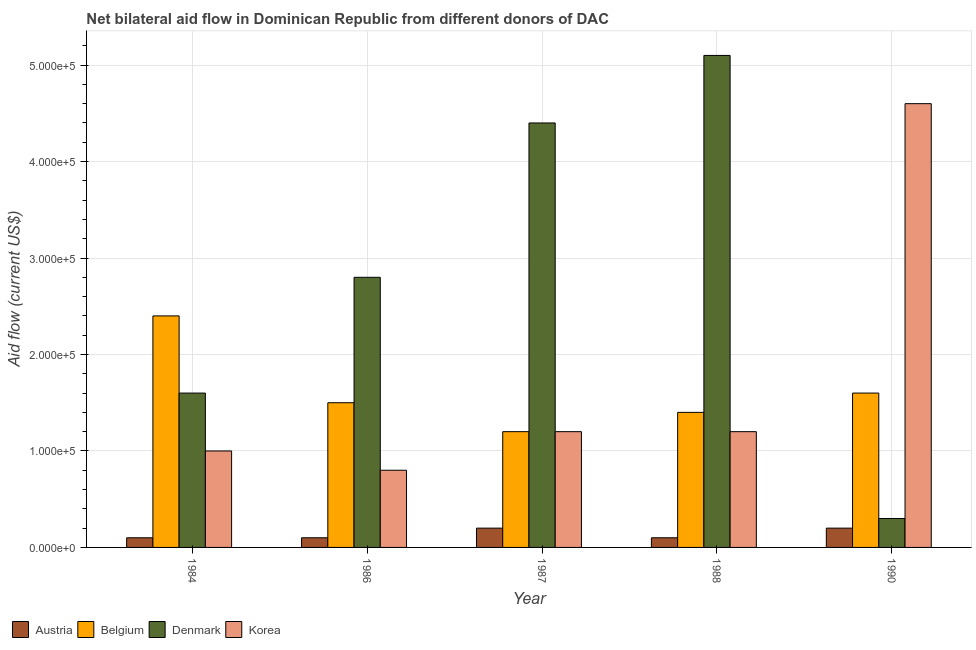How many different coloured bars are there?
Offer a terse response. 4. How many bars are there on the 5th tick from the right?
Ensure brevity in your answer.  4. In how many cases, is the number of bars for a given year not equal to the number of legend labels?
Provide a succinct answer. 0. What is the amount of aid given by austria in 1990?
Your response must be concise. 2.00e+04. Across all years, what is the maximum amount of aid given by belgium?
Offer a terse response. 2.40e+05. Across all years, what is the minimum amount of aid given by belgium?
Give a very brief answer. 1.20e+05. What is the total amount of aid given by korea in the graph?
Ensure brevity in your answer.  8.80e+05. What is the difference between the amount of aid given by austria in 1987 and that in 1988?
Make the answer very short. 10000. What is the difference between the amount of aid given by korea in 1988 and the amount of aid given by belgium in 1986?
Provide a short and direct response. 4.00e+04. What is the average amount of aid given by belgium per year?
Make the answer very short. 1.62e+05. In the year 1987, what is the difference between the amount of aid given by austria and amount of aid given by belgium?
Give a very brief answer. 0. In how many years, is the amount of aid given by belgium greater than 60000 US$?
Make the answer very short. 5. What is the ratio of the amount of aid given by korea in 1988 to that in 1990?
Your answer should be compact. 0.26. What is the difference between the highest and the lowest amount of aid given by denmark?
Give a very brief answer. 4.80e+05. Is it the case that in every year, the sum of the amount of aid given by denmark and amount of aid given by korea is greater than the sum of amount of aid given by austria and amount of aid given by belgium?
Keep it short and to the point. No. What does the 4th bar from the left in 1984 represents?
Your answer should be very brief. Korea. What does the 1st bar from the right in 1986 represents?
Your answer should be compact. Korea. Is it the case that in every year, the sum of the amount of aid given by austria and amount of aid given by belgium is greater than the amount of aid given by denmark?
Offer a very short reply. No. How many bars are there?
Your response must be concise. 20. How many years are there in the graph?
Ensure brevity in your answer.  5. What is the difference between two consecutive major ticks on the Y-axis?
Keep it short and to the point. 1.00e+05. Are the values on the major ticks of Y-axis written in scientific E-notation?
Make the answer very short. Yes. How many legend labels are there?
Offer a very short reply. 4. What is the title of the graph?
Your answer should be very brief. Net bilateral aid flow in Dominican Republic from different donors of DAC. Does "UNPBF" appear as one of the legend labels in the graph?
Offer a terse response. No. What is the label or title of the X-axis?
Offer a very short reply. Year. What is the Aid flow (current US$) in Austria in 1984?
Provide a short and direct response. 10000. What is the Aid flow (current US$) in Belgium in 1984?
Ensure brevity in your answer.  2.40e+05. What is the Aid flow (current US$) in Denmark in 1984?
Ensure brevity in your answer.  1.60e+05. What is the Aid flow (current US$) of Austria in 1986?
Provide a succinct answer. 10000. What is the Aid flow (current US$) of Belgium in 1986?
Keep it short and to the point. 1.50e+05. What is the Aid flow (current US$) in Austria in 1987?
Provide a short and direct response. 2.00e+04. What is the Aid flow (current US$) in Korea in 1987?
Your answer should be compact. 1.20e+05. What is the Aid flow (current US$) in Austria in 1988?
Offer a very short reply. 10000. What is the Aid flow (current US$) in Denmark in 1988?
Keep it short and to the point. 5.10e+05. What is the Aid flow (current US$) in Korea in 1988?
Ensure brevity in your answer.  1.20e+05. What is the Aid flow (current US$) in Austria in 1990?
Your response must be concise. 2.00e+04. Across all years, what is the maximum Aid flow (current US$) in Austria?
Offer a terse response. 2.00e+04. Across all years, what is the maximum Aid flow (current US$) in Belgium?
Your answer should be very brief. 2.40e+05. Across all years, what is the maximum Aid flow (current US$) in Denmark?
Provide a short and direct response. 5.10e+05. Across all years, what is the maximum Aid flow (current US$) in Korea?
Your answer should be compact. 4.60e+05. Across all years, what is the minimum Aid flow (current US$) of Belgium?
Offer a very short reply. 1.20e+05. Across all years, what is the minimum Aid flow (current US$) of Korea?
Your answer should be compact. 8.00e+04. What is the total Aid flow (current US$) of Belgium in the graph?
Provide a succinct answer. 8.10e+05. What is the total Aid flow (current US$) of Denmark in the graph?
Give a very brief answer. 1.42e+06. What is the total Aid flow (current US$) in Korea in the graph?
Your response must be concise. 8.80e+05. What is the difference between the Aid flow (current US$) in Austria in 1984 and that in 1986?
Your answer should be compact. 0. What is the difference between the Aid flow (current US$) in Belgium in 1984 and that in 1986?
Your answer should be very brief. 9.00e+04. What is the difference between the Aid flow (current US$) in Denmark in 1984 and that in 1986?
Your answer should be very brief. -1.20e+05. What is the difference between the Aid flow (current US$) in Denmark in 1984 and that in 1987?
Keep it short and to the point. -2.80e+05. What is the difference between the Aid flow (current US$) in Korea in 1984 and that in 1987?
Your answer should be compact. -2.00e+04. What is the difference between the Aid flow (current US$) of Denmark in 1984 and that in 1988?
Your answer should be compact. -3.50e+05. What is the difference between the Aid flow (current US$) in Korea in 1984 and that in 1988?
Give a very brief answer. -2.00e+04. What is the difference between the Aid flow (current US$) in Austria in 1984 and that in 1990?
Your answer should be very brief. -10000. What is the difference between the Aid flow (current US$) of Denmark in 1984 and that in 1990?
Your answer should be very brief. 1.30e+05. What is the difference between the Aid flow (current US$) in Korea in 1984 and that in 1990?
Your answer should be very brief. -3.60e+05. What is the difference between the Aid flow (current US$) of Denmark in 1986 and that in 1987?
Your answer should be compact. -1.60e+05. What is the difference between the Aid flow (current US$) in Denmark in 1986 and that in 1988?
Your response must be concise. -2.30e+05. What is the difference between the Aid flow (current US$) of Korea in 1986 and that in 1988?
Provide a short and direct response. -4.00e+04. What is the difference between the Aid flow (current US$) of Belgium in 1986 and that in 1990?
Your response must be concise. -10000. What is the difference between the Aid flow (current US$) of Denmark in 1986 and that in 1990?
Your response must be concise. 2.50e+05. What is the difference between the Aid flow (current US$) of Korea in 1986 and that in 1990?
Your answer should be compact. -3.80e+05. What is the difference between the Aid flow (current US$) of Belgium in 1987 and that in 1988?
Your answer should be compact. -2.00e+04. What is the difference between the Aid flow (current US$) in Belgium in 1988 and that in 1990?
Offer a terse response. -2.00e+04. What is the difference between the Aid flow (current US$) in Denmark in 1988 and that in 1990?
Provide a short and direct response. 4.80e+05. What is the difference between the Aid flow (current US$) in Korea in 1988 and that in 1990?
Provide a succinct answer. -3.40e+05. What is the difference between the Aid flow (current US$) in Austria in 1984 and the Aid flow (current US$) in Denmark in 1986?
Keep it short and to the point. -2.70e+05. What is the difference between the Aid flow (current US$) in Austria in 1984 and the Aid flow (current US$) in Korea in 1986?
Give a very brief answer. -7.00e+04. What is the difference between the Aid flow (current US$) of Belgium in 1984 and the Aid flow (current US$) of Denmark in 1986?
Provide a succinct answer. -4.00e+04. What is the difference between the Aid flow (current US$) in Belgium in 1984 and the Aid flow (current US$) in Korea in 1986?
Keep it short and to the point. 1.60e+05. What is the difference between the Aid flow (current US$) of Denmark in 1984 and the Aid flow (current US$) of Korea in 1986?
Your answer should be very brief. 8.00e+04. What is the difference between the Aid flow (current US$) of Austria in 1984 and the Aid flow (current US$) of Belgium in 1987?
Your answer should be very brief. -1.10e+05. What is the difference between the Aid flow (current US$) of Austria in 1984 and the Aid flow (current US$) of Denmark in 1987?
Your response must be concise. -4.30e+05. What is the difference between the Aid flow (current US$) of Belgium in 1984 and the Aid flow (current US$) of Korea in 1987?
Provide a short and direct response. 1.20e+05. What is the difference between the Aid flow (current US$) in Denmark in 1984 and the Aid flow (current US$) in Korea in 1987?
Give a very brief answer. 4.00e+04. What is the difference between the Aid flow (current US$) in Austria in 1984 and the Aid flow (current US$) in Denmark in 1988?
Make the answer very short. -5.00e+05. What is the difference between the Aid flow (current US$) of Belgium in 1984 and the Aid flow (current US$) of Denmark in 1988?
Keep it short and to the point. -2.70e+05. What is the difference between the Aid flow (current US$) in Belgium in 1984 and the Aid flow (current US$) in Korea in 1988?
Provide a short and direct response. 1.20e+05. What is the difference between the Aid flow (current US$) in Denmark in 1984 and the Aid flow (current US$) in Korea in 1988?
Ensure brevity in your answer.  4.00e+04. What is the difference between the Aid flow (current US$) in Austria in 1984 and the Aid flow (current US$) in Belgium in 1990?
Make the answer very short. -1.50e+05. What is the difference between the Aid flow (current US$) of Austria in 1984 and the Aid flow (current US$) of Denmark in 1990?
Give a very brief answer. -2.00e+04. What is the difference between the Aid flow (current US$) of Austria in 1984 and the Aid flow (current US$) of Korea in 1990?
Your answer should be compact. -4.50e+05. What is the difference between the Aid flow (current US$) in Belgium in 1984 and the Aid flow (current US$) in Denmark in 1990?
Give a very brief answer. 2.10e+05. What is the difference between the Aid flow (current US$) of Belgium in 1984 and the Aid flow (current US$) of Korea in 1990?
Offer a terse response. -2.20e+05. What is the difference between the Aid flow (current US$) in Austria in 1986 and the Aid flow (current US$) in Belgium in 1987?
Your response must be concise. -1.10e+05. What is the difference between the Aid flow (current US$) in Austria in 1986 and the Aid flow (current US$) in Denmark in 1987?
Provide a succinct answer. -4.30e+05. What is the difference between the Aid flow (current US$) of Belgium in 1986 and the Aid flow (current US$) of Denmark in 1987?
Your answer should be compact. -2.90e+05. What is the difference between the Aid flow (current US$) in Belgium in 1986 and the Aid flow (current US$) in Korea in 1987?
Provide a short and direct response. 3.00e+04. What is the difference between the Aid flow (current US$) in Austria in 1986 and the Aid flow (current US$) in Denmark in 1988?
Give a very brief answer. -5.00e+05. What is the difference between the Aid flow (current US$) of Belgium in 1986 and the Aid flow (current US$) of Denmark in 1988?
Give a very brief answer. -3.60e+05. What is the difference between the Aid flow (current US$) of Austria in 1986 and the Aid flow (current US$) of Korea in 1990?
Your response must be concise. -4.50e+05. What is the difference between the Aid flow (current US$) of Belgium in 1986 and the Aid flow (current US$) of Korea in 1990?
Provide a succinct answer. -3.10e+05. What is the difference between the Aid flow (current US$) in Denmark in 1986 and the Aid flow (current US$) in Korea in 1990?
Your answer should be compact. -1.80e+05. What is the difference between the Aid flow (current US$) in Austria in 1987 and the Aid flow (current US$) in Belgium in 1988?
Make the answer very short. -1.20e+05. What is the difference between the Aid flow (current US$) in Austria in 1987 and the Aid flow (current US$) in Denmark in 1988?
Your answer should be compact. -4.90e+05. What is the difference between the Aid flow (current US$) in Belgium in 1987 and the Aid flow (current US$) in Denmark in 1988?
Give a very brief answer. -3.90e+05. What is the difference between the Aid flow (current US$) in Belgium in 1987 and the Aid flow (current US$) in Korea in 1988?
Offer a terse response. 0. What is the difference between the Aid flow (current US$) of Austria in 1987 and the Aid flow (current US$) of Belgium in 1990?
Your response must be concise. -1.40e+05. What is the difference between the Aid flow (current US$) in Austria in 1987 and the Aid flow (current US$) in Denmark in 1990?
Give a very brief answer. -10000. What is the difference between the Aid flow (current US$) of Austria in 1987 and the Aid flow (current US$) of Korea in 1990?
Make the answer very short. -4.40e+05. What is the difference between the Aid flow (current US$) in Denmark in 1987 and the Aid flow (current US$) in Korea in 1990?
Make the answer very short. -2.00e+04. What is the difference between the Aid flow (current US$) of Austria in 1988 and the Aid flow (current US$) of Denmark in 1990?
Make the answer very short. -2.00e+04. What is the difference between the Aid flow (current US$) of Austria in 1988 and the Aid flow (current US$) of Korea in 1990?
Your answer should be compact. -4.50e+05. What is the difference between the Aid flow (current US$) of Belgium in 1988 and the Aid flow (current US$) of Denmark in 1990?
Keep it short and to the point. 1.10e+05. What is the difference between the Aid flow (current US$) of Belgium in 1988 and the Aid flow (current US$) of Korea in 1990?
Ensure brevity in your answer.  -3.20e+05. What is the average Aid flow (current US$) in Austria per year?
Provide a short and direct response. 1.40e+04. What is the average Aid flow (current US$) of Belgium per year?
Provide a succinct answer. 1.62e+05. What is the average Aid flow (current US$) of Denmark per year?
Offer a terse response. 2.84e+05. What is the average Aid flow (current US$) of Korea per year?
Provide a short and direct response. 1.76e+05. In the year 1984, what is the difference between the Aid flow (current US$) in Austria and Aid flow (current US$) in Denmark?
Your response must be concise. -1.50e+05. In the year 1986, what is the difference between the Aid flow (current US$) in Austria and Aid flow (current US$) in Denmark?
Give a very brief answer. -2.70e+05. In the year 1987, what is the difference between the Aid flow (current US$) in Austria and Aid flow (current US$) in Belgium?
Keep it short and to the point. -1.00e+05. In the year 1987, what is the difference between the Aid flow (current US$) in Austria and Aid flow (current US$) in Denmark?
Make the answer very short. -4.20e+05. In the year 1987, what is the difference between the Aid flow (current US$) in Austria and Aid flow (current US$) in Korea?
Make the answer very short. -1.00e+05. In the year 1987, what is the difference between the Aid flow (current US$) in Belgium and Aid flow (current US$) in Denmark?
Your answer should be very brief. -3.20e+05. In the year 1988, what is the difference between the Aid flow (current US$) of Austria and Aid flow (current US$) of Belgium?
Offer a very short reply. -1.30e+05. In the year 1988, what is the difference between the Aid flow (current US$) of Austria and Aid flow (current US$) of Denmark?
Make the answer very short. -5.00e+05. In the year 1988, what is the difference between the Aid flow (current US$) of Austria and Aid flow (current US$) of Korea?
Offer a terse response. -1.10e+05. In the year 1988, what is the difference between the Aid flow (current US$) in Belgium and Aid flow (current US$) in Denmark?
Provide a succinct answer. -3.70e+05. In the year 1988, what is the difference between the Aid flow (current US$) in Denmark and Aid flow (current US$) in Korea?
Provide a short and direct response. 3.90e+05. In the year 1990, what is the difference between the Aid flow (current US$) in Austria and Aid flow (current US$) in Korea?
Keep it short and to the point. -4.40e+05. In the year 1990, what is the difference between the Aid flow (current US$) of Denmark and Aid flow (current US$) of Korea?
Your response must be concise. -4.30e+05. What is the ratio of the Aid flow (current US$) in Belgium in 1984 to that in 1986?
Your answer should be very brief. 1.6. What is the ratio of the Aid flow (current US$) in Korea in 1984 to that in 1986?
Your answer should be compact. 1.25. What is the ratio of the Aid flow (current US$) of Belgium in 1984 to that in 1987?
Give a very brief answer. 2. What is the ratio of the Aid flow (current US$) of Denmark in 1984 to that in 1987?
Give a very brief answer. 0.36. What is the ratio of the Aid flow (current US$) in Korea in 1984 to that in 1987?
Your answer should be compact. 0.83. What is the ratio of the Aid flow (current US$) in Austria in 1984 to that in 1988?
Provide a succinct answer. 1. What is the ratio of the Aid flow (current US$) in Belgium in 1984 to that in 1988?
Provide a succinct answer. 1.71. What is the ratio of the Aid flow (current US$) of Denmark in 1984 to that in 1988?
Provide a short and direct response. 0.31. What is the ratio of the Aid flow (current US$) in Austria in 1984 to that in 1990?
Your answer should be very brief. 0.5. What is the ratio of the Aid flow (current US$) of Denmark in 1984 to that in 1990?
Keep it short and to the point. 5.33. What is the ratio of the Aid flow (current US$) in Korea in 1984 to that in 1990?
Your answer should be very brief. 0.22. What is the ratio of the Aid flow (current US$) in Belgium in 1986 to that in 1987?
Provide a succinct answer. 1.25. What is the ratio of the Aid flow (current US$) of Denmark in 1986 to that in 1987?
Give a very brief answer. 0.64. What is the ratio of the Aid flow (current US$) of Belgium in 1986 to that in 1988?
Provide a short and direct response. 1.07. What is the ratio of the Aid flow (current US$) of Denmark in 1986 to that in 1988?
Provide a succinct answer. 0.55. What is the ratio of the Aid flow (current US$) in Austria in 1986 to that in 1990?
Offer a terse response. 0.5. What is the ratio of the Aid flow (current US$) in Belgium in 1986 to that in 1990?
Offer a very short reply. 0.94. What is the ratio of the Aid flow (current US$) of Denmark in 1986 to that in 1990?
Provide a succinct answer. 9.33. What is the ratio of the Aid flow (current US$) of Korea in 1986 to that in 1990?
Offer a very short reply. 0.17. What is the ratio of the Aid flow (current US$) in Austria in 1987 to that in 1988?
Ensure brevity in your answer.  2. What is the ratio of the Aid flow (current US$) of Denmark in 1987 to that in 1988?
Make the answer very short. 0.86. What is the ratio of the Aid flow (current US$) of Korea in 1987 to that in 1988?
Keep it short and to the point. 1. What is the ratio of the Aid flow (current US$) in Austria in 1987 to that in 1990?
Your answer should be very brief. 1. What is the ratio of the Aid flow (current US$) of Belgium in 1987 to that in 1990?
Offer a very short reply. 0.75. What is the ratio of the Aid flow (current US$) of Denmark in 1987 to that in 1990?
Keep it short and to the point. 14.67. What is the ratio of the Aid flow (current US$) in Korea in 1987 to that in 1990?
Provide a succinct answer. 0.26. What is the ratio of the Aid flow (current US$) of Belgium in 1988 to that in 1990?
Your response must be concise. 0.88. What is the ratio of the Aid flow (current US$) of Korea in 1988 to that in 1990?
Give a very brief answer. 0.26. What is the difference between the highest and the second highest Aid flow (current US$) of Austria?
Provide a succinct answer. 0. What is the difference between the highest and the second highest Aid flow (current US$) of Belgium?
Offer a very short reply. 8.00e+04. What is the difference between the highest and the second highest Aid flow (current US$) of Denmark?
Provide a short and direct response. 7.00e+04. What is the difference between the highest and the second highest Aid flow (current US$) in Korea?
Keep it short and to the point. 3.40e+05. What is the difference between the highest and the lowest Aid flow (current US$) of Austria?
Your answer should be very brief. 10000. What is the difference between the highest and the lowest Aid flow (current US$) of Korea?
Offer a terse response. 3.80e+05. 